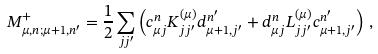<formula> <loc_0><loc_0><loc_500><loc_500>M _ { \mu , n ; \mu + 1 , n ^ { \prime } } ^ { + } = \frac { 1 } { 2 } \sum _ { j j ^ { \prime } } \left ( c _ { \mu j } ^ { n } K _ { j j ^ { \prime } } ^ { ( \mu ) } d _ { \mu + 1 , j ^ { \prime } } ^ { n ^ { \prime } } + d _ { \mu j } ^ { n } L _ { j j ^ { \prime } } ^ { ( \mu ) } c _ { \mu + 1 , j ^ { \prime } } ^ { n ^ { \prime } } \right ) \, ,</formula> 